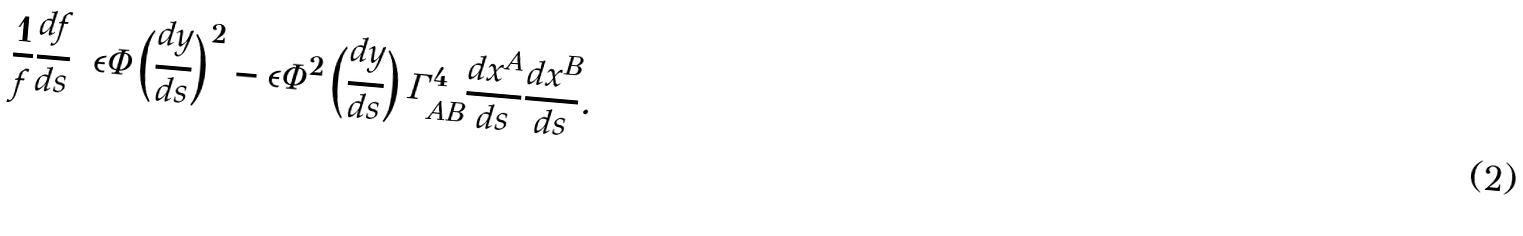<formula> <loc_0><loc_0><loc_500><loc_500>\frac { 1 } { f } \frac { d f } { d s } = \epsilon \Phi \left ( \frac { d y } { d s } \right ) ^ { 2 } - \epsilon \Phi ^ { 2 } \left ( \frac { d y } { d s } \right ) \Gamma ^ { 4 } _ { A B } \frac { d x ^ { A } } { d s } \frac { d x ^ { B } } { d s } .</formula> 